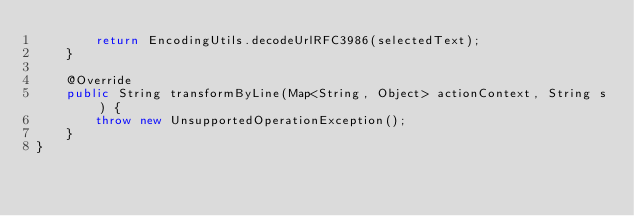Convert code to text. <code><loc_0><loc_0><loc_500><loc_500><_Java_>        return EncodingUtils.decodeUrlRFC3986(selectedText);
    }

    @Override
    public String transformByLine(Map<String, Object> actionContext, String s) {
        throw new UnsupportedOperationException();
    }
}</code> 